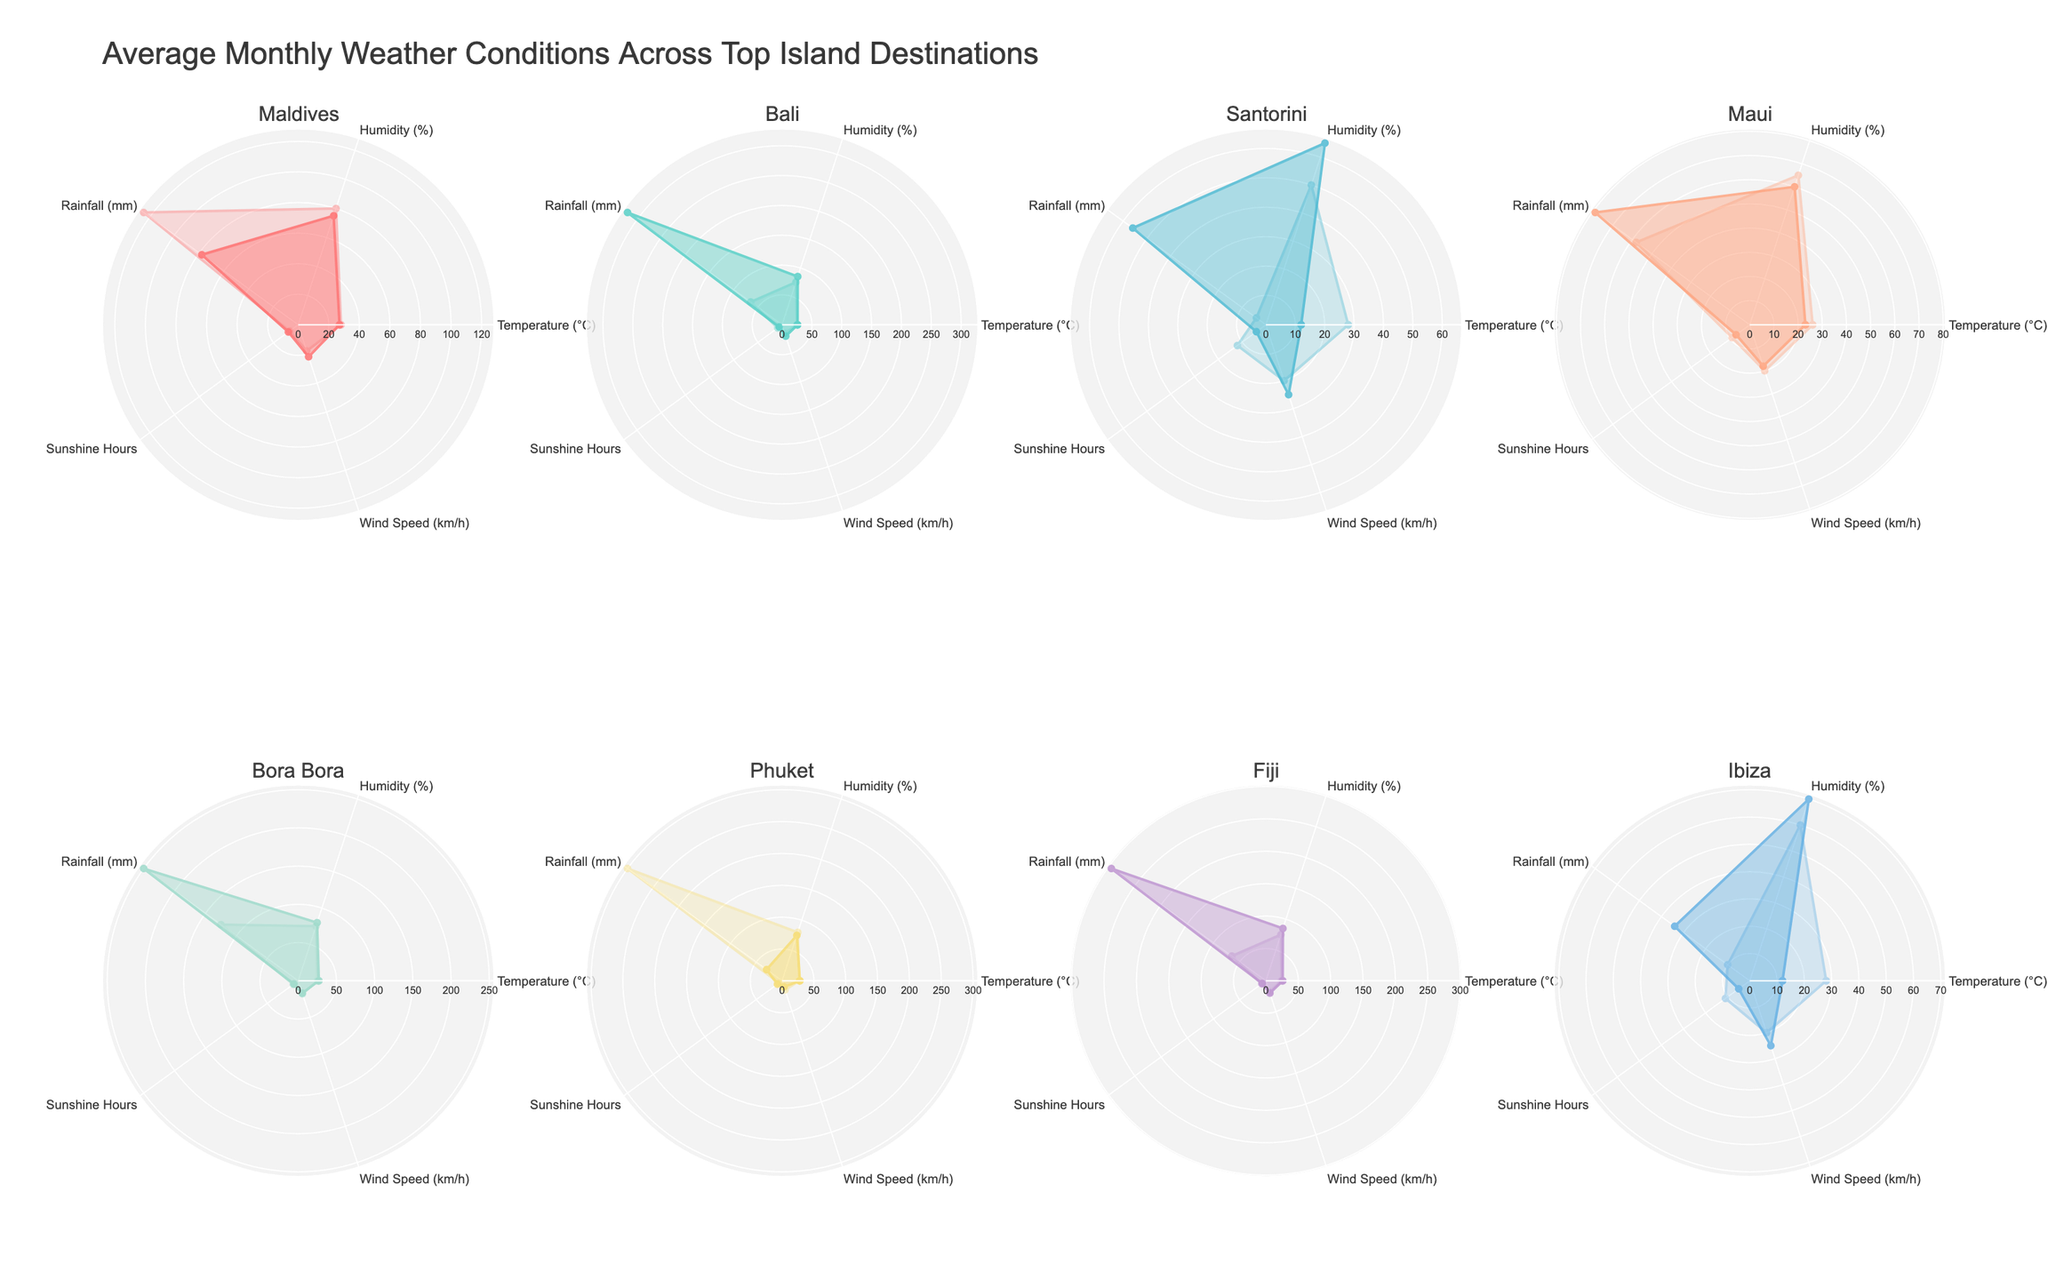Which island destination has the highest temperature in January? Look at the temperature data for each destination in January and find which has the highest value. Maldives, Bora Bora, and Phuket all have a temperature of 27°C in January, which is the highest.
Answer: Maldives, Bora Bora, Phuket Which destination has the lowest average humidity in July? Check the humidity values for each destination in July, then calculate the average humidity and find the lowest. Santorini has the lowest humidity in July with 50%.
Answer: Santorini What is the difference in wind speed between Phuket in January and Santorini in July? Find the wind speed for Phuket in January and Santorini in July in the data. Phuket's wind speed in January is 10 km/h and Santorini's in July is 20 km/h. The difference is 20 km/h - 10 km/h = 10 km/h.
Answer: 10 km/h Which island has the highest rainfall in January? Identify the rainfall values for all destinations in January and find the highest. Bali has the highest rainfall with 320 mm in January.
Answer: Bali What's the average temperature across all island destinations in July? Sum the temperatures in July for all destinations and divide by the number of destinations. The temperatures are 28, 25, 28, 26, 25, 27, 24, 28. The total is 211 and the average is 211/8 = 26.375°C.
Answer: 26.375°C Which island has more sunshine hours in January, Bali or Maui? Compare the sunshine hours for Bali and Maui in January. Bali has 6 sunshine hours while Maui has 7. Hence, Maui has more sunshine hours.
Answer: Maui Is the rainfall in Bora Bora higher in January or July? Compare the rainfall values for Bora Bora in January and July. For January, it is 250 mm and for July, it is 125 mm. January has higher rainfall.
Answer: January Which has a higher temperature in January, Santorini or Ibiza? Find temperatures for Santorini and Ibiza in January and compare. Santorini has 12°C while Ibiza has the same 12°C in January. Both have equal temperatures.
Answer: Equal Which island destination experiences stronger winds in January, Maldives or Ibiza? Compare the wind speed values for Maldives and Ibiza in January. Maldives has 22 km/h while Ibiza has 25 km/h. Ibiza experiences stronger winds.
Answer: Ibiza 